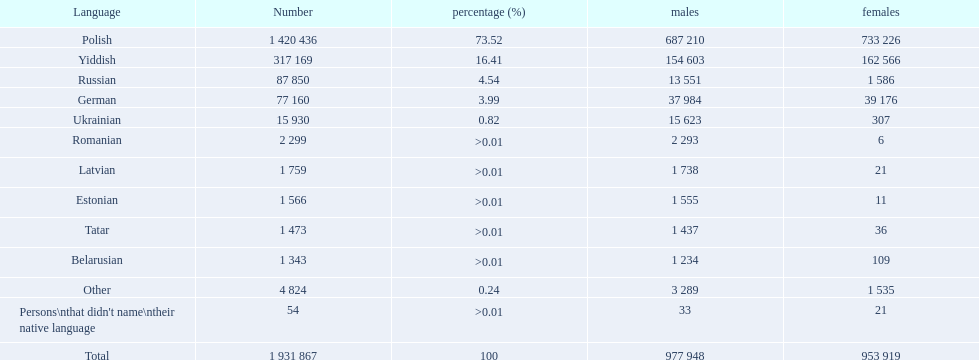What are the dialects used in the warsaw governorate? Polish, Yiddish, Russian, German, Ukrainian, Romanian, Latvian, Estonian, Tatar, Belarusian, Other. What fraction of the population speaks polish? 73.52. What is the next highest ratio? 16.41. Which language is associated with this ratio? Yiddish. 